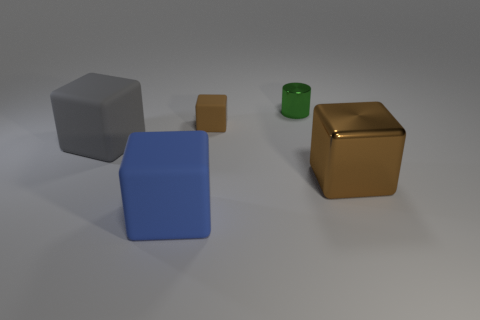Add 4 tiny green cylinders. How many objects exist? 9 Subtract all shiny blocks. How many blocks are left? 3 Subtract all gray blocks. How many blocks are left? 3 Subtract 3 cubes. How many cubes are left? 1 Subtract all cyan cubes. How many cyan cylinders are left? 0 Subtract all big things. Subtract all tiny cubes. How many objects are left? 1 Add 3 tiny things. How many tiny things are left? 5 Add 5 large brown rubber cylinders. How many large brown rubber cylinders exist? 5 Subtract 0 cyan cylinders. How many objects are left? 5 Subtract all blocks. How many objects are left? 1 